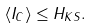<formula> <loc_0><loc_0><loc_500><loc_500>\langle I _ { C } \rangle \leq H _ { K S } .</formula> 